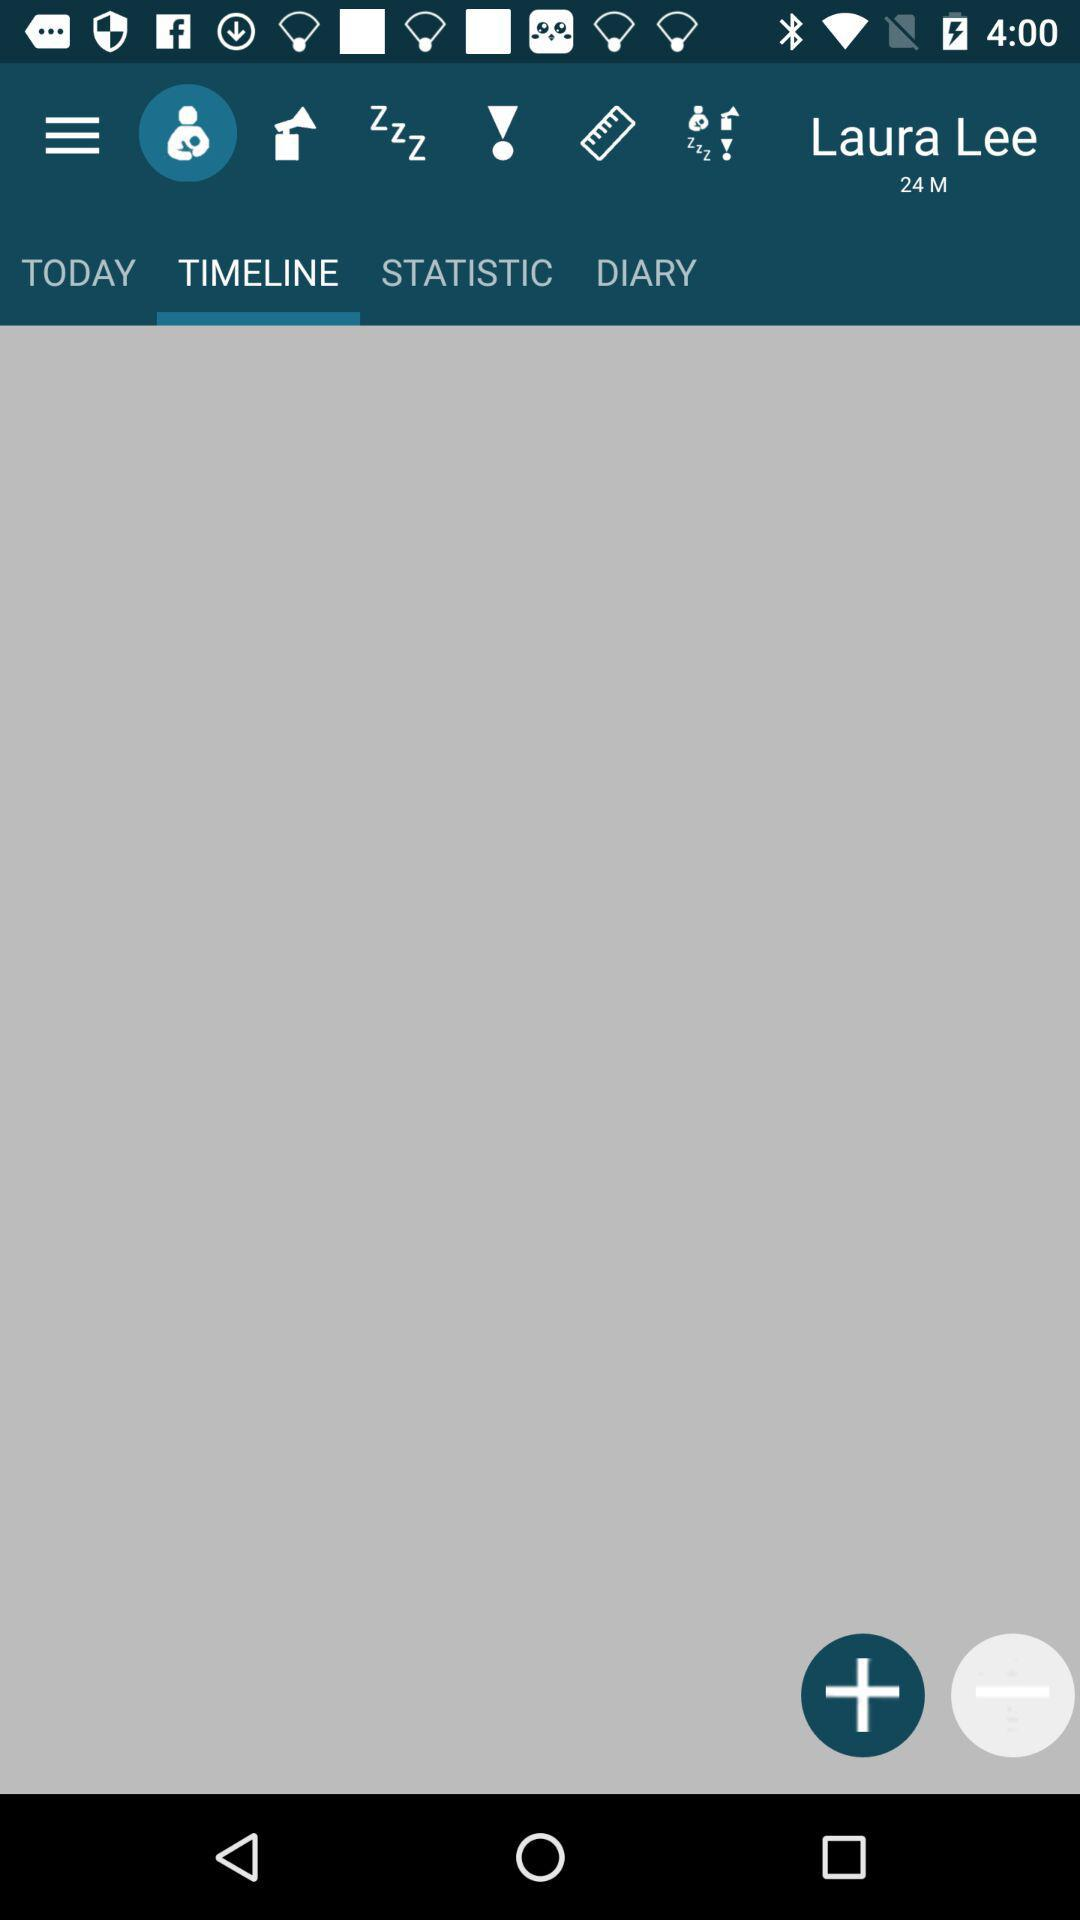What is the name of the baby? The name of the baby is Laura Lee. 